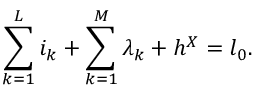Convert formula to latex. <formula><loc_0><loc_0><loc_500><loc_500>\sum _ { k = 1 } ^ { L } i _ { k } + \sum _ { k = 1 } ^ { M } \lambda _ { k } + h ^ { X } = l _ { 0 } .</formula> 